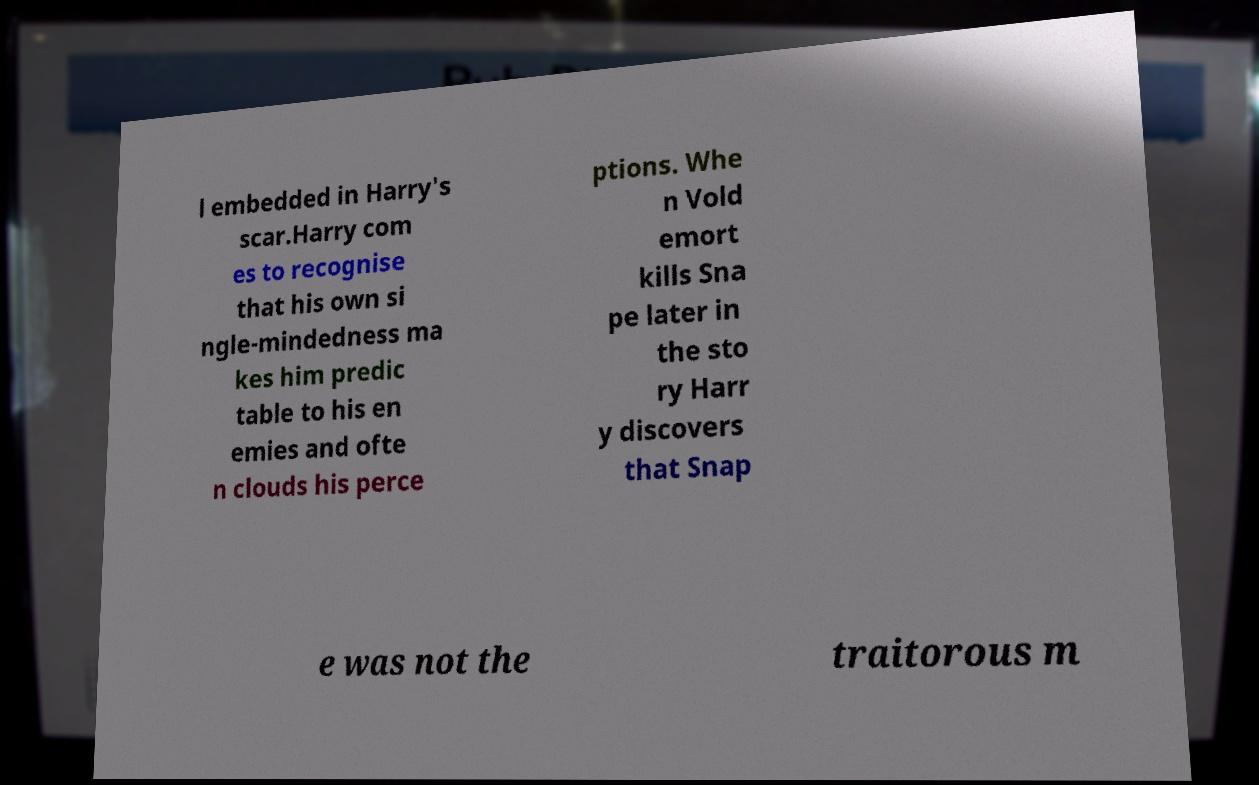Could you extract and type out the text from this image? l embedded in Harry's scar.Harry com es to recognise that his own si ngle-mindedness ma kes him predic table to his en emies and ofte n clouds his perce ptions. Whe n Vold emort kills Sna pe later in the sto ry Harr y discovers that Snap e was not the traitorous m 